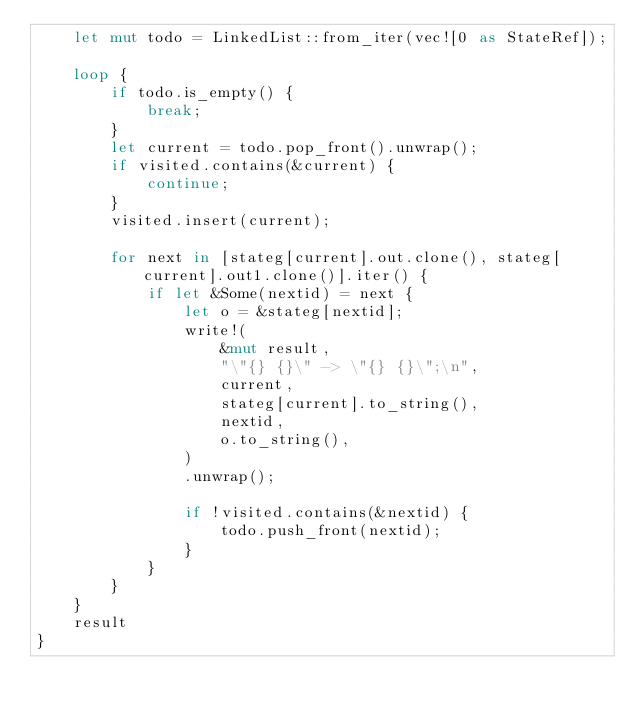Convert code to text. <code><loc_0><loc_0><loc_500><loc_500><_Rust_>    let mut todo = LinkedList::from_iter(vec![0 as StateRef]);

    loop {
        if todo.is_empty() {
            break;
        }
        let current = todo.pop_front().unwrap();
        if visited.contains(&current) {
            continue;
        }
        visited.insert(current);

        for next in [stateg[current].out.clone(), stateg[current].out1.clone()].iter() {
            if let &Some(nextid) = next {
                let o = &stateg[nextid];
                write!(
                    &mut result,
                    "\"{} {}\" -> \"{} {}\";\n",
                    current,
                    stateg[current].to_string(),
                    nextid,
                    o.to_string(),
                )
                .unwrap();

                if !visited.contains(&nextid) {
                    todo.push_front(nextid);
                }
            }
        }
    }
    result
}
</code> 